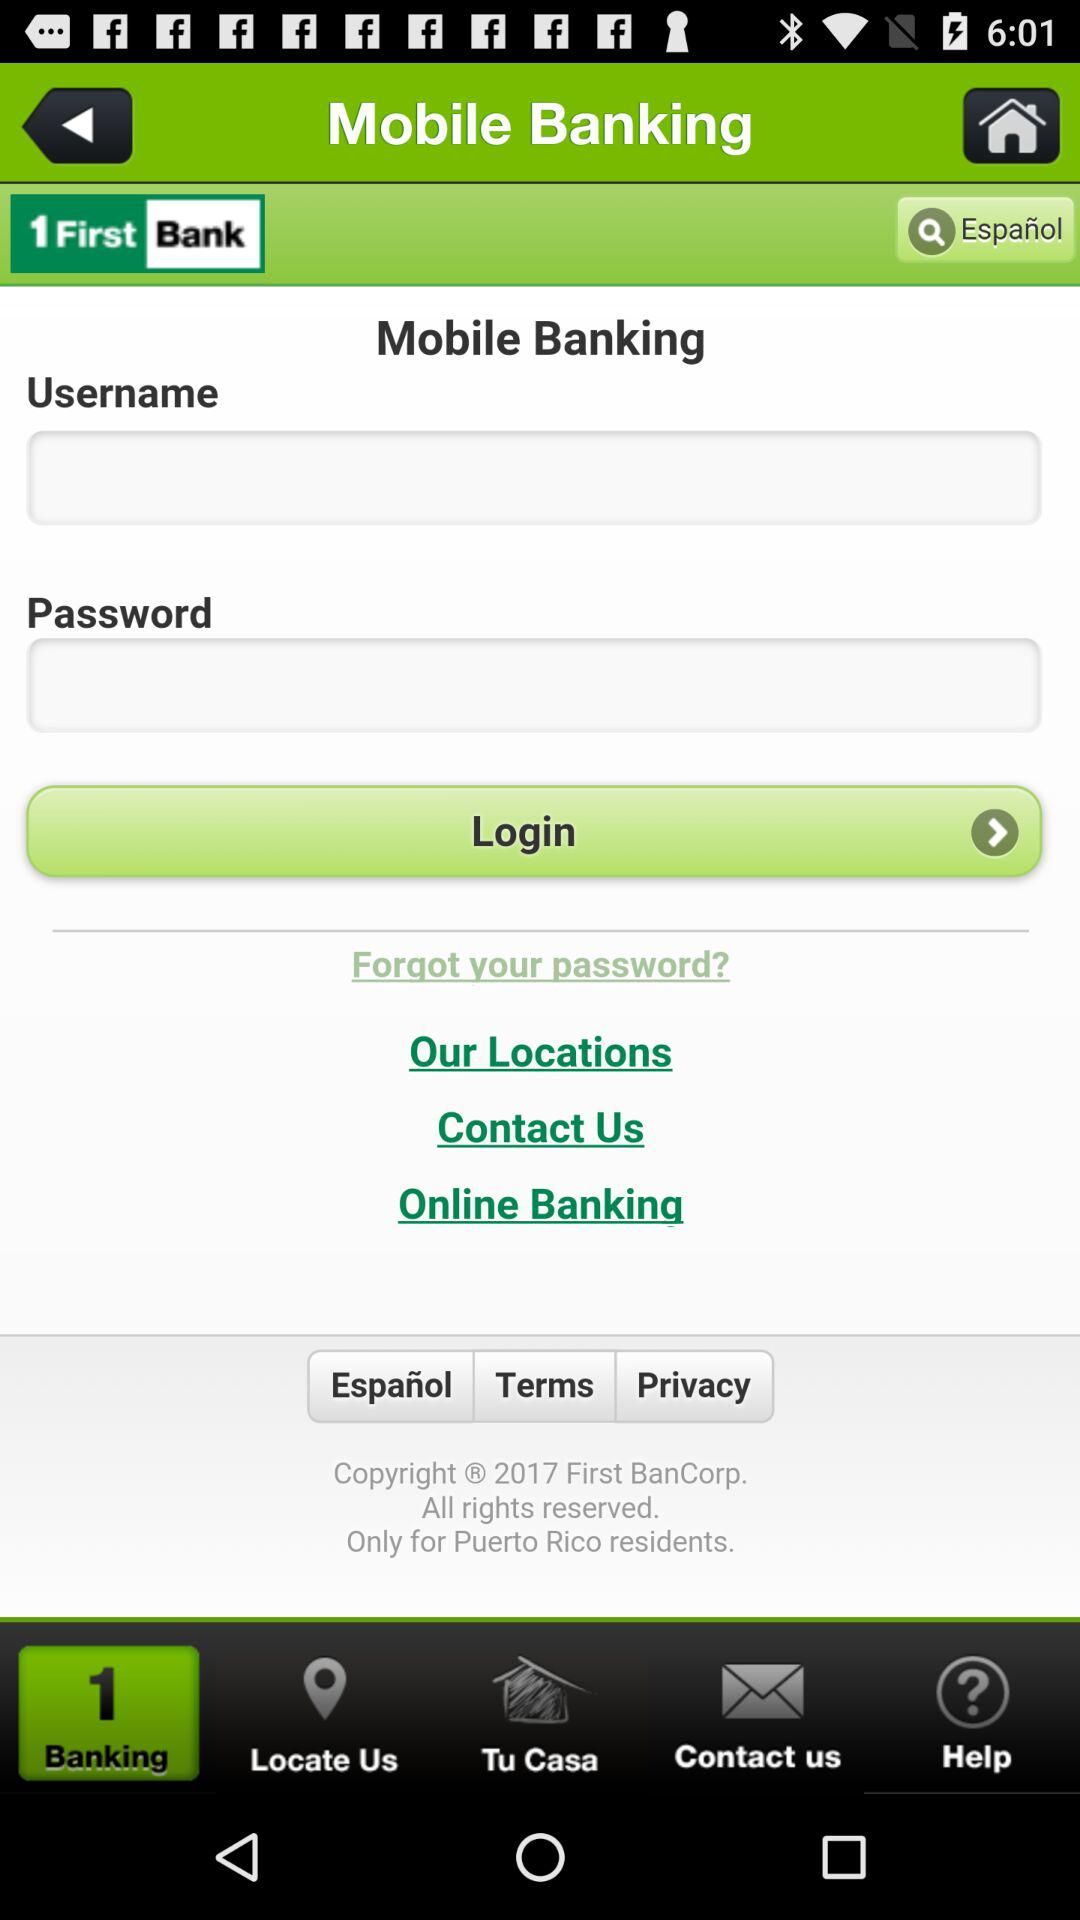What are the requirements to log in? The requirements are username and password. 